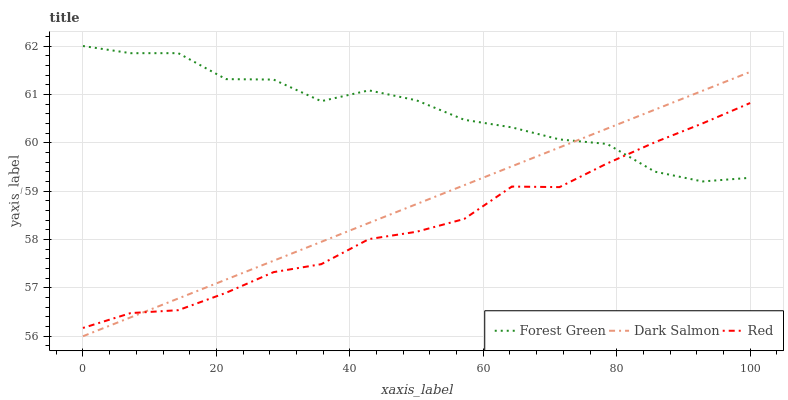Does Red have the minimum area under the curve?
Answer yes or no. Yes. Does Forest Green have the maximum area under the curve?
Answer yes or no. Yes. Does Dark Salmon have the minimum area under the curve?
Answer yes or no. No. Does Dark Salmon have the maximum area under the curve?
Answer yes or no. No. Is Dark Salmon the smoothest?
Answer yes or no. Yes. Is Forest Green the roughest?
Answer yes or no. Yes. Is Red the smoothest?
Answer yes or no. No. Is Red the roughest?
Answer yes or no. No. Does Dark Salmon have the lowest value?
Answer yes or no. Yes. Does Red have the lowest value?
Answer yes or no. No. Does Forest Green have the highest value?
Answer yes or no. Yes. Does Dark Salmon have the highest value?
Answer yes or no. No. Does Forest Green intersect Dark Salmon?
Answer yes or no. Yes. Is Forest Green less than Dark Salmon?
Answer yes or no. No. Is Forest Green greater than Dark Salmon?
Answer yes or no. No. 